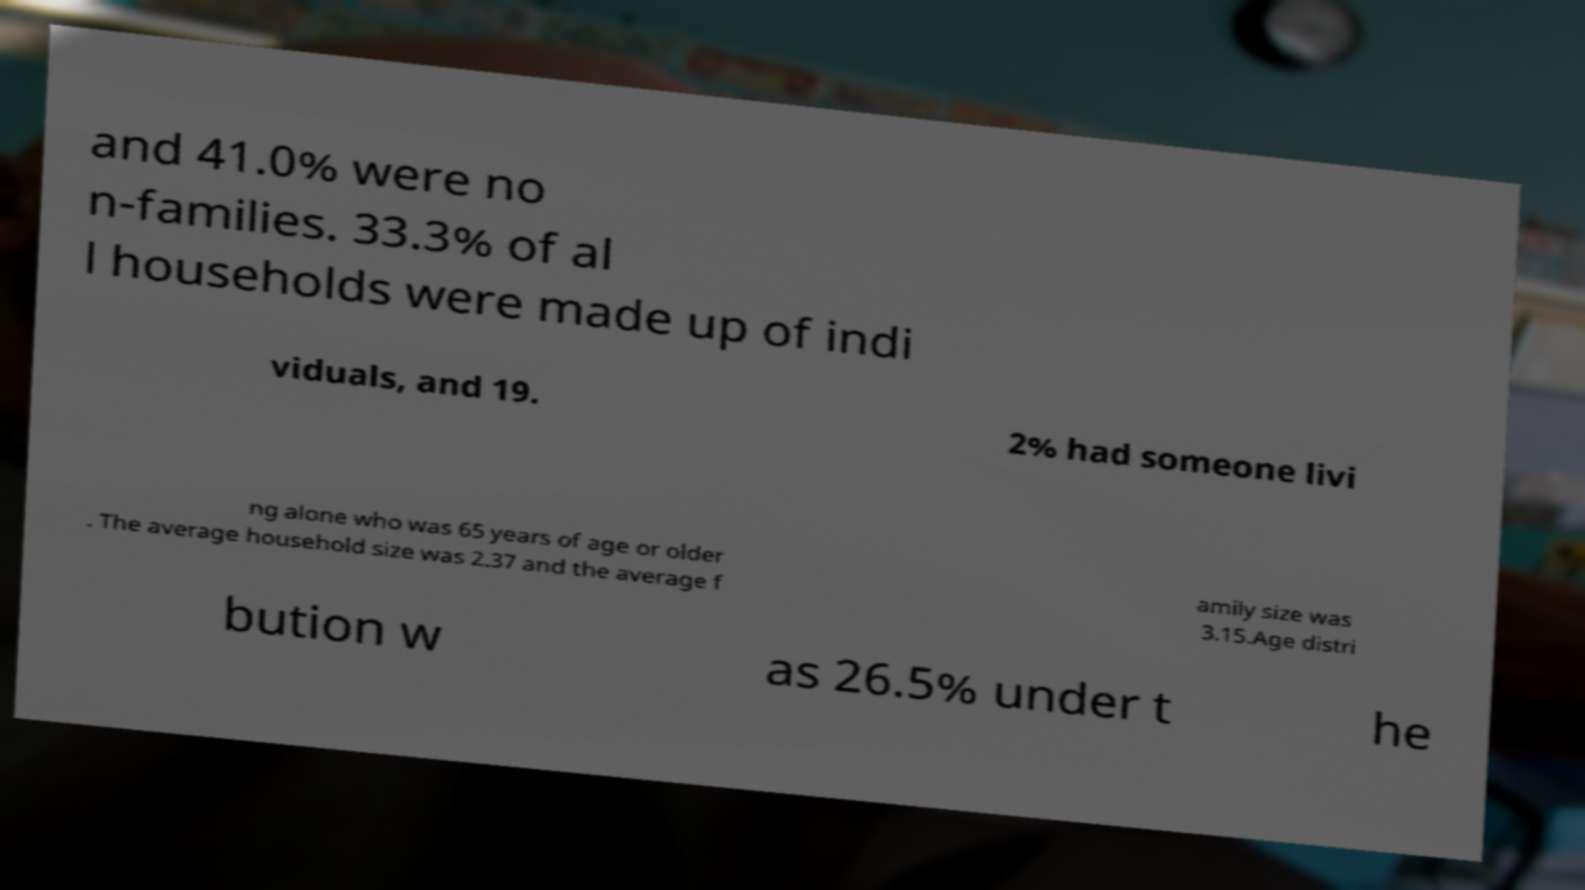Can you accurately transcribe the text from the provided image for me? and 41.0% were no n-families. 33.3% of al l households were made up of indi viduals, and 19. 2% had someone livi ng alone who was 65 years of age or older . The average household size was 2.37 and the average f amily size was 3.15.Age distri bution w as 26.5% under t he 